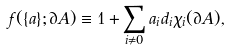Convert formula to latex. <formula><loc_0><loc_0><loc_500><loc_500>f ( \{ a \} ; \partial A ) \equiv 1 + \sum _ { i \neq 0 } a _ { i } d _ { i } \chi _ { i } ( \partial A ) ,</formula> 